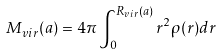<formula> <loc_0><loc_0><loc_500><loc_500>M _ { v i r } ( a ) = 4 \pi \int _ { 0 } ^ { R _ { v i r } ( a ) } r ^ { 2 } \rho ( r ) d r</formula> 